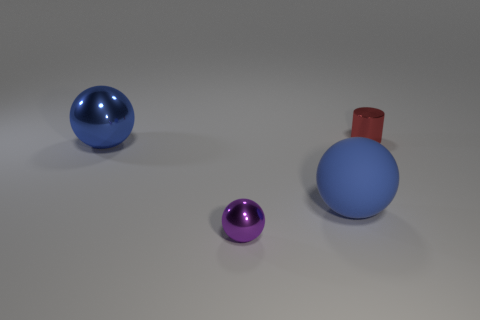Is the shape of the blue matte thing the same as the purple thing?
Provide a short and direct response. Yes. How many other things are the same size as the cylinder?
Give a very brief answer. 1. What color is the large metal ball?
Your answer should be compact. Blue. How many big things are red objects or blue rubber cylinders?
Offer a terse response. 0. Is the size of the sphere left of the purple ball the same as the purple object in front of the large blue rubber sphere?
Make the answer very short. No. The other metallic object that is the same shape as the small purple object is what size?
Your answer should be very brief. Large. Is the number of blue objects in front of the tiny purple metallic thing greater than the number of large shiny things that are behind the small red cylinder?
Give a very brief answer. No. What material is the thing that is both on the left side of the matte thing and in front of the big blue metal thing?
Provide a succinct answer. Metal. What color is the other large matte object that is the same shape as the purple object?
Offer a terse response. Blue. What size is the metal cylinder?
Give a very brief answer. Small. 